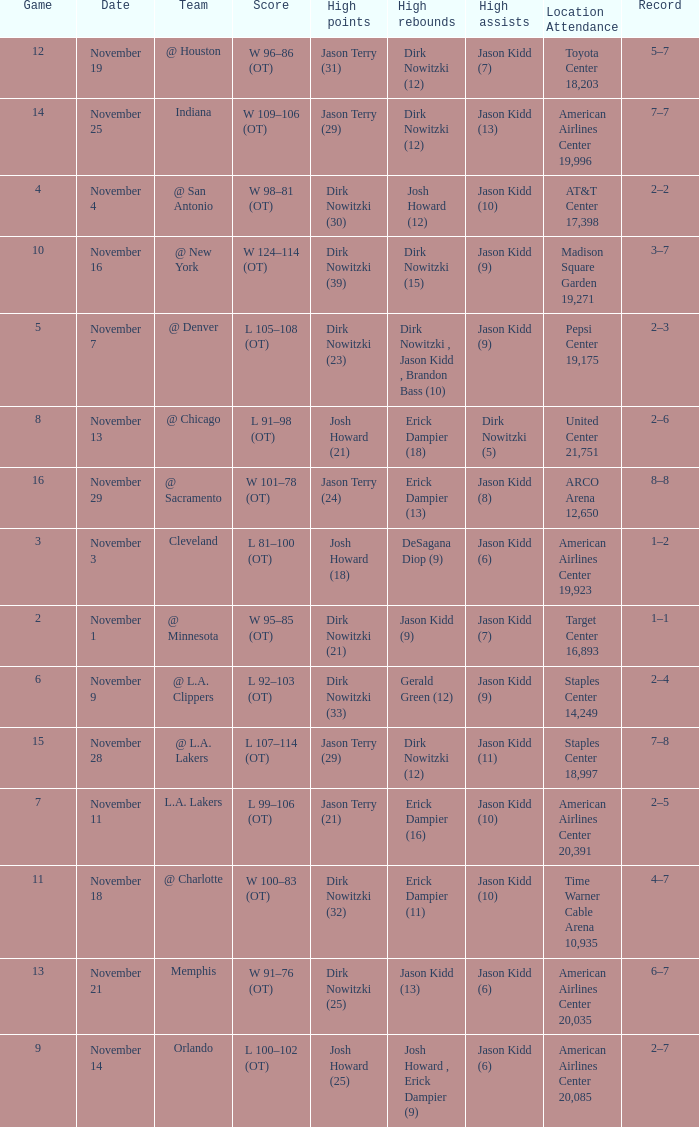What is High Rebounds, when High Assists is "Jason Kidd (13)"? Dirk Nowitzki (12). 